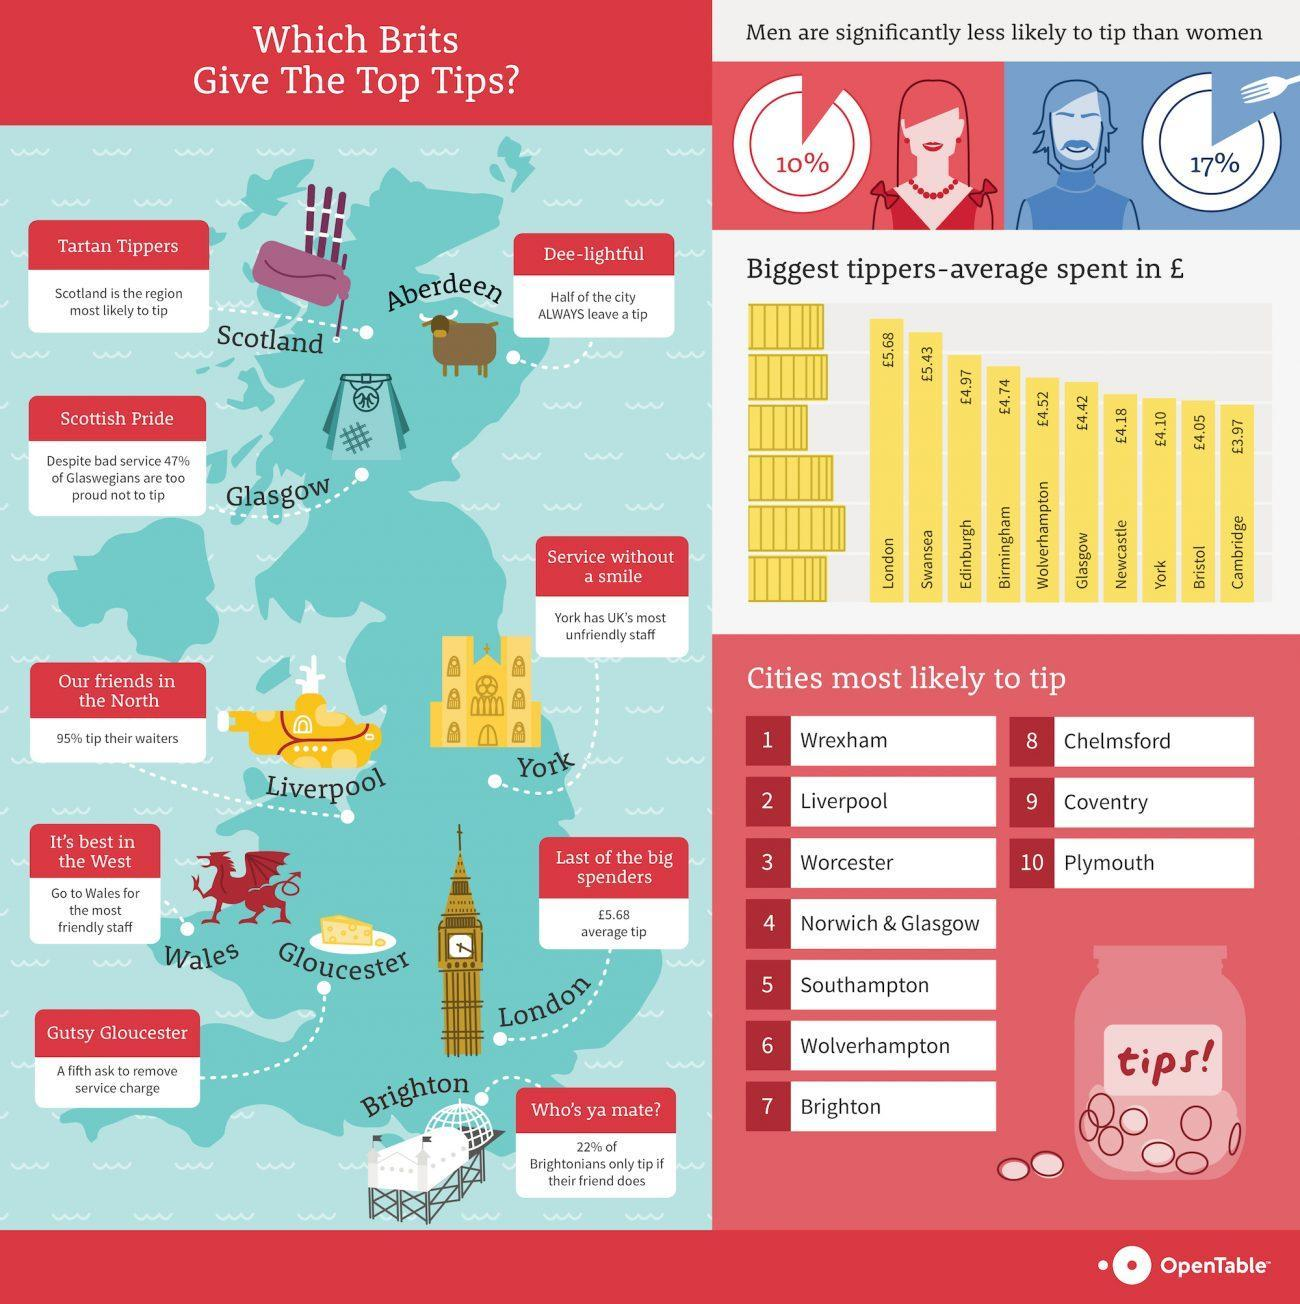What is the average money spent (in £) by the biggest tippers in Bristol?
Answer the question with a short phrase. £4.05 What is the average money spent (in £) by the biggest tippers in London? £5.68 What percent of tippers in UK are females? 10% What percent of tippers in UK are males? 17% What percentage of people in Liverpool city do not tip their waiters? 5% What is the average money spent (in £) by the biggest tippers in Cambridge? £3.97 